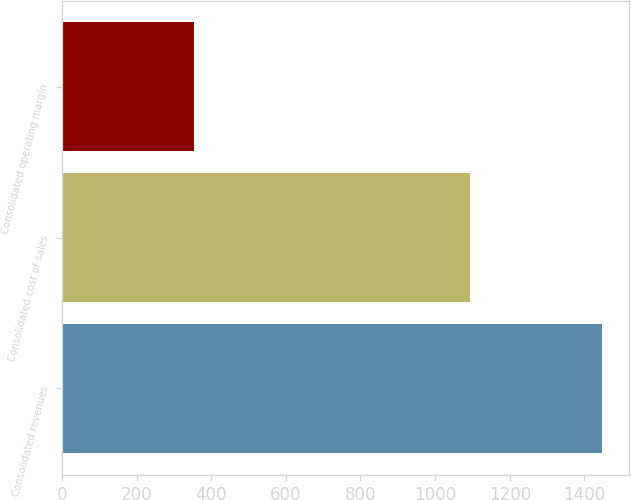Convert chart to OTSL. <chart><loc_0><loc_0><loc_500><loc_500><bar_chart><fcel>Consolidated revenues<fcel>Consolidated cost of sales<fcel>Consolidated operating margin<nl><fcel>1446.5<fcel>1092.8<fcel>353.7<nl></chart> 